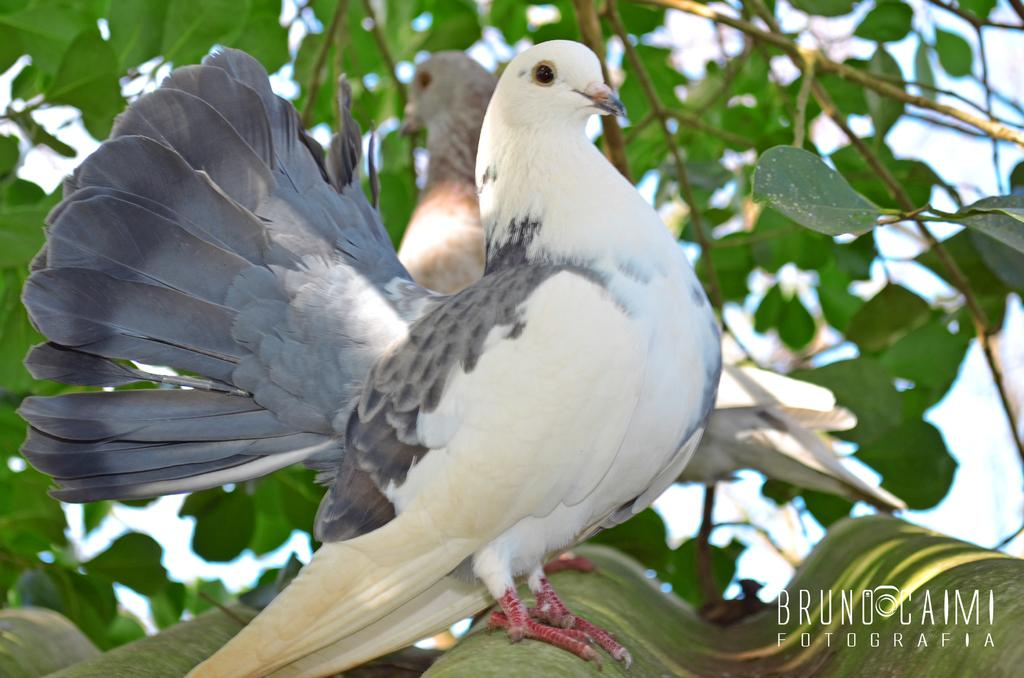What animals can be seen in the foreground of the image? There are two pigeons on a roof in the foreground of the image. What type of vegetation is visible behind the roof? There is a tree visible behind the roof. What can be seen in the background of the image? The sky is visible in the background of the image. How many crows are perched on the tree in the image? There are no crows present in the image; only two pigeons are visible on the roof. Are there any cats visible in the image? There are no cats present in the image. 